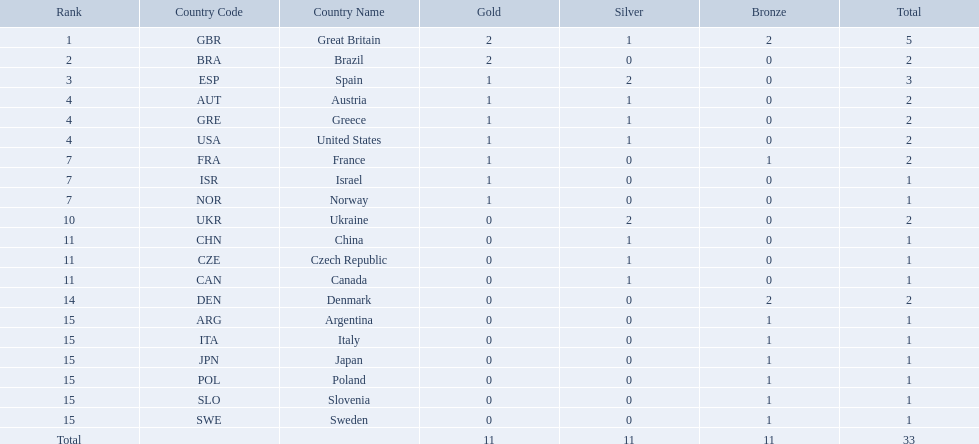Could you help me parse every detail presented in this table? {'header': ['Rank', 'Country Code', 'Country Name', 'Gold', 'Silver', 'Bronze', 'Total'], 'rows': [['1', 'GBR', 'Great Britain', '2', '1', '2', '5'], ['2', 'BRA', 'Brazil', '2', '0', '0', '2'], ['3', 'ESP', 'Spain', '1', '2', '0', '3'], ['4', 'AUT', 'Austria', '1', '1', '0', '2'], ['4', 'GRE', 'Greece', '1', '1', '0', '2'], ['4', 'USA', 'United States', '1', '1', '0', '2'], ['7', 'FRA', 'France', '1', '0', '1', '2'], ['7', 'ISR', 'Israel', '1', '0', '0', '1'], ['7', 'NOR', 'Norway', '1', '0', '0', '1'], ['10', 'UKR', 'Ukraine', '0', '2', '0', '2'], ['11', 'CHN', 'China', '0', '1', '0', '1'], ['11', 'CZE', 'Czech Republic', '0', '1', '0', '1'], ['11', 'CAN', 'Canada', '0', '1', '0', '1'], ['14', 'DEN', 'Denmark', '0', '0', '2', '2'], ['15', 'ARG', 'Argentina', '0', '0', '1', '1'], ['15', 'ITA', 'Italy', '0', '0', '1', '1'], ['15', 'JPN', 'Japan', '0', '0', '1', '1'], ['15', 'POL', 'Poland', '0', '0', '1', '1'], ['15', 'SLO', 'Slovenia', '0', '0', '1', '1'], ['15', 'SWE', 'Sweden', '0', '0', '1', '1'], ['Total', '', '', '11', '11', '11', '33']]} How many medals did each country receive? 5, 2, 3, 2, 2, 2, 2, 1, 1, 2, 1, 1, 1, 2, 1, 1, 1, 1, 1, 1. Which country received 3 medals? Spain (ESP). 